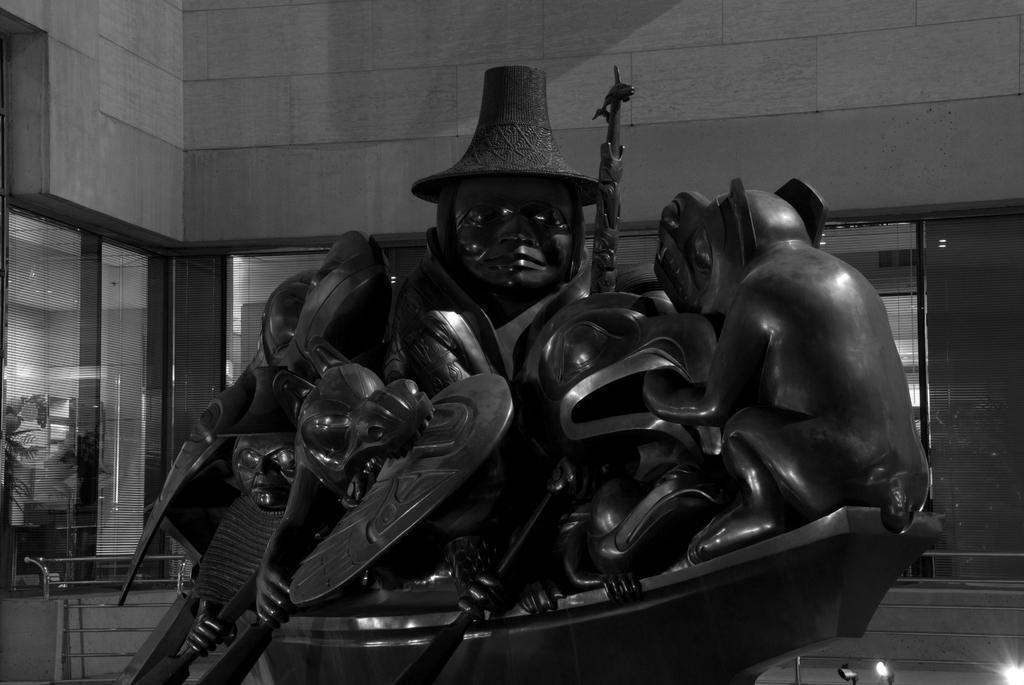Could you give a brief overview of what you see in this image? In this picture there is a statue of few persons sitting in a boat and there is a building behind it and there are few lights in the right bottom corner. 